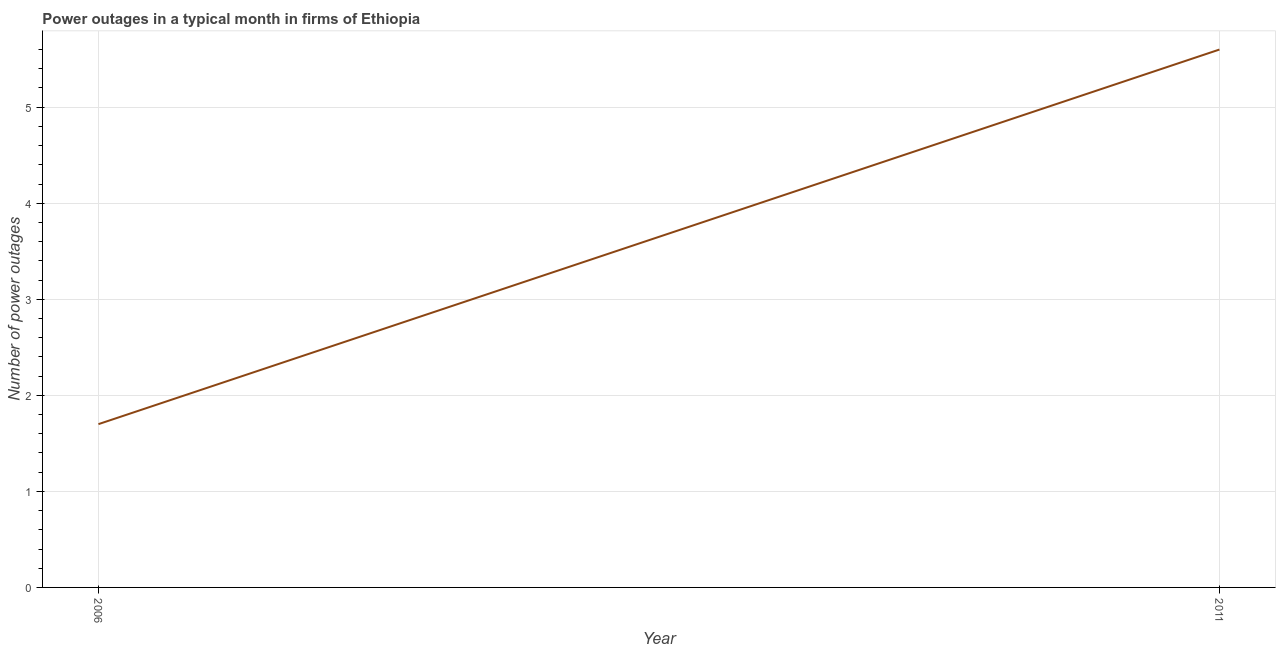Across all years, what is the minimum number of power outages?
Provide a succinct answer. 1.7. In which year was the number of power outages maximum?
Your answer should be very brief. 2011. What is the difference between the number of power outages in 2006 and 2011?
Keep it short and to the point. -3.9. What is the average number of power outages per year?
Provide a short and direct response. 3.65. What is the median number of power outages?
Ensure brevity in your answer.  3.65. Do a majority of the years between 2006 and 2011 (inclusive) have number of power outages greater than 4 ?
Offer a very short reply. No. What is the ratio of the number of power outages in 2006 to that in 2011?
Keep it short and to the point. 0.3. Is the number of power outages in 2006 less than that in 2011?
Offer a terse response. Yes. Does the number of power outages monotonically increase over the years?
Provide a succinct answer. Yes. How many lines are there?
Provide a succinct answer. 1. How many years are there in the graph?
Make the answer very short. 2. What is the difference between two consecutive major ticks on the Y-axis?
Give a very brief answer. 1. Does the graph contain any zero values?
Your response must be concise. No. What is the title of the graph?
Make the answer very short. Power outages in a typical month in firms of Ethiopia. What is the label or title of the X-axis?
Give a very brief answer. Year. What is the label or title of the Y-axis?
Your response must be concise. Number of power outages. What is the Number of power outages in 2006?
Offer a terse response. 1.7. What is the Number of power outages in 2011?
Your answer should be very brief. 5.6. What is the difference between the Number of power outages in 2006 and 2011?
Your response must be concise. -3.9. What is the ratio of the Number of power outages in 2006 to that in 2011?
Provide a succinct answer. 0.3. 